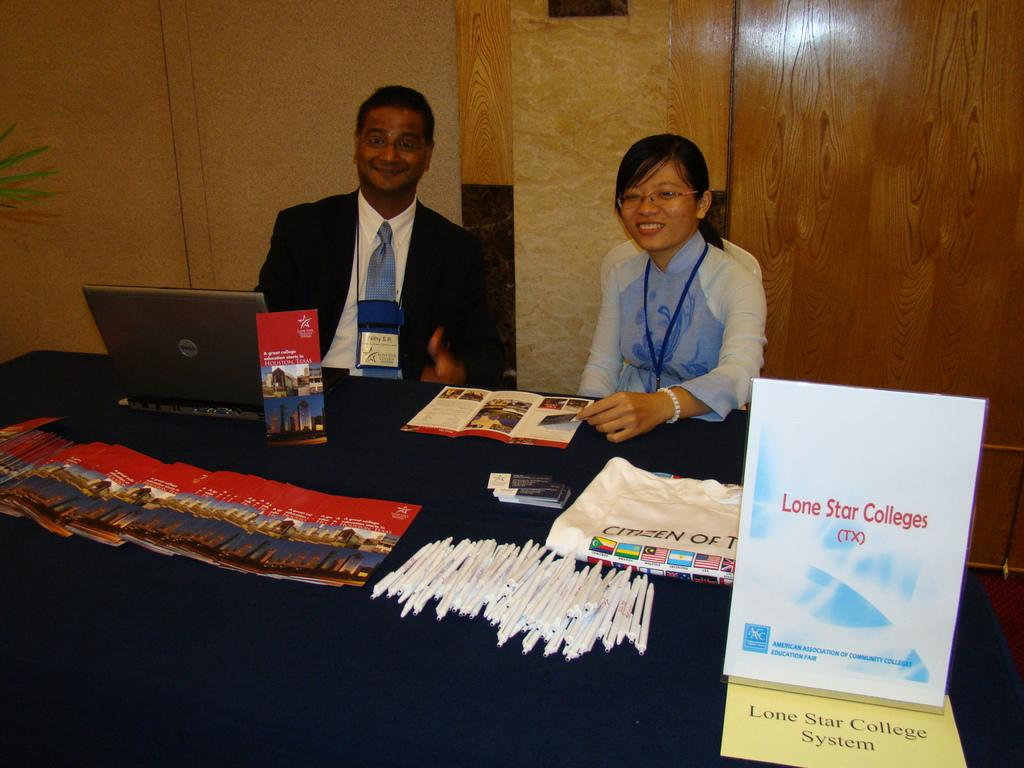<image>
Provide a brief description of the given image. Two representatives sit at an information table for Lone Star Colleges. 